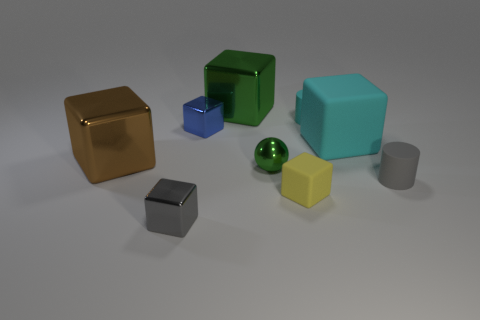Are there more tiny green shiny balls that are in front of the tiny metal sphere than big brown metallic blocks?
Your answer should be very brief. No. What is the material of the object that is on the right side of the tiny cyan matte cylinder and left of the gray rubber cylinder?
Offer a terse response. Rubber. Is there anything else that has the same shape as the big green thing?
Your answer should be very brief. Yes. What number of shiny things are behind the cyan cube and to the left of the tiny blue shiny thing?
Make the answer very short. 0. What is the tiny blue thing made of?
Make the answer very short. Metal. Are there an equal number of gray things that are to the left of the big cyan matte cube and large objects?
Keep it short and to the point. No. How many large green objects are the same shape as the gray matte thing?
Provide a short and direct response. 0. Is the shape of the small green object the same as the brown thing?
Give a very brief answer. No. What number of things are things in front of the green shiny cube or cyan matte cubes?
Your answer should be compact. 8. What shape is the tiny gray thing that is behind the metallic thing in front of the gray thing that is to the right of the green metallic sphere?
Make the answer very short. Cylinder. 